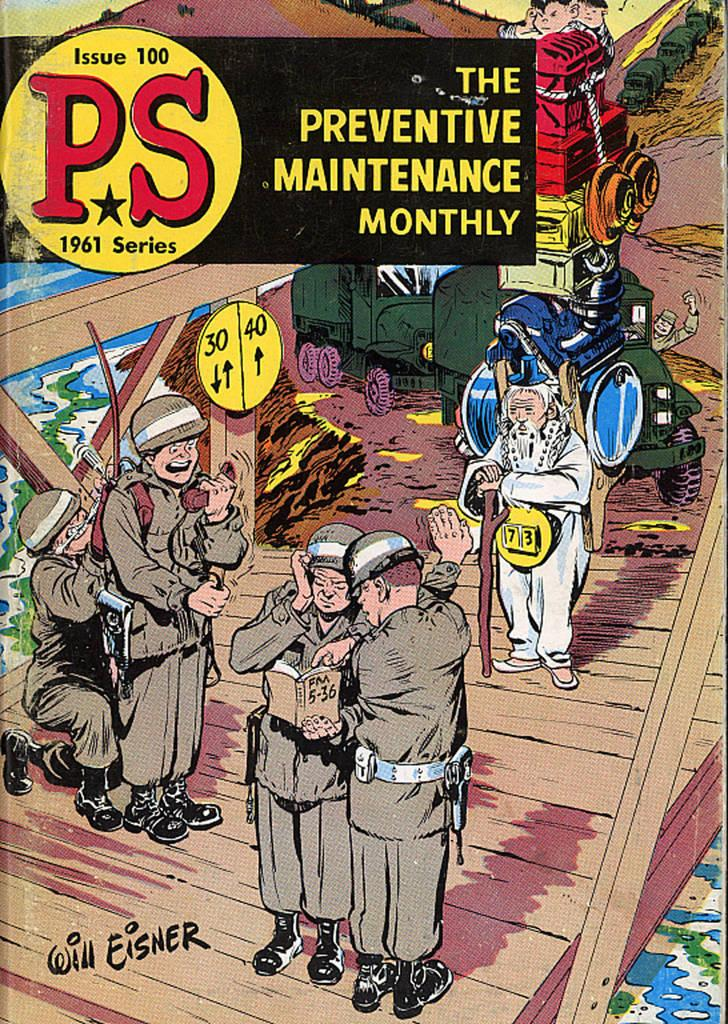<image>
Write a terse but informative summary of the picture. A comic book of soldiers that says The Preventive Maintenance Monthly. 